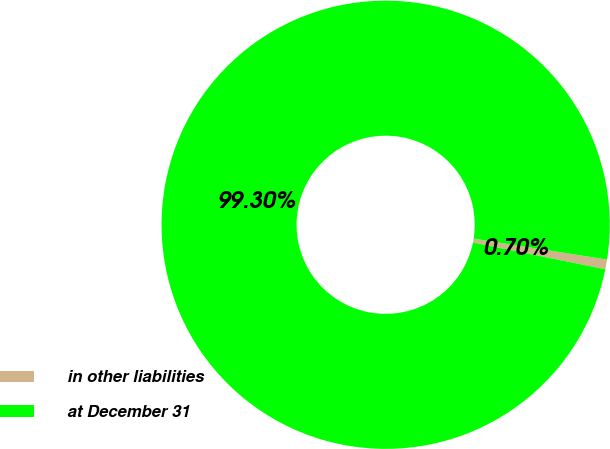Convert chart. <chart><loc_0><loc_0><loc_500><loc_500><pie_chart><fcel>in other liabilities<fcel>at December 31<nl><fcel>0.7%<fcel>99.3%<nl></chart> 